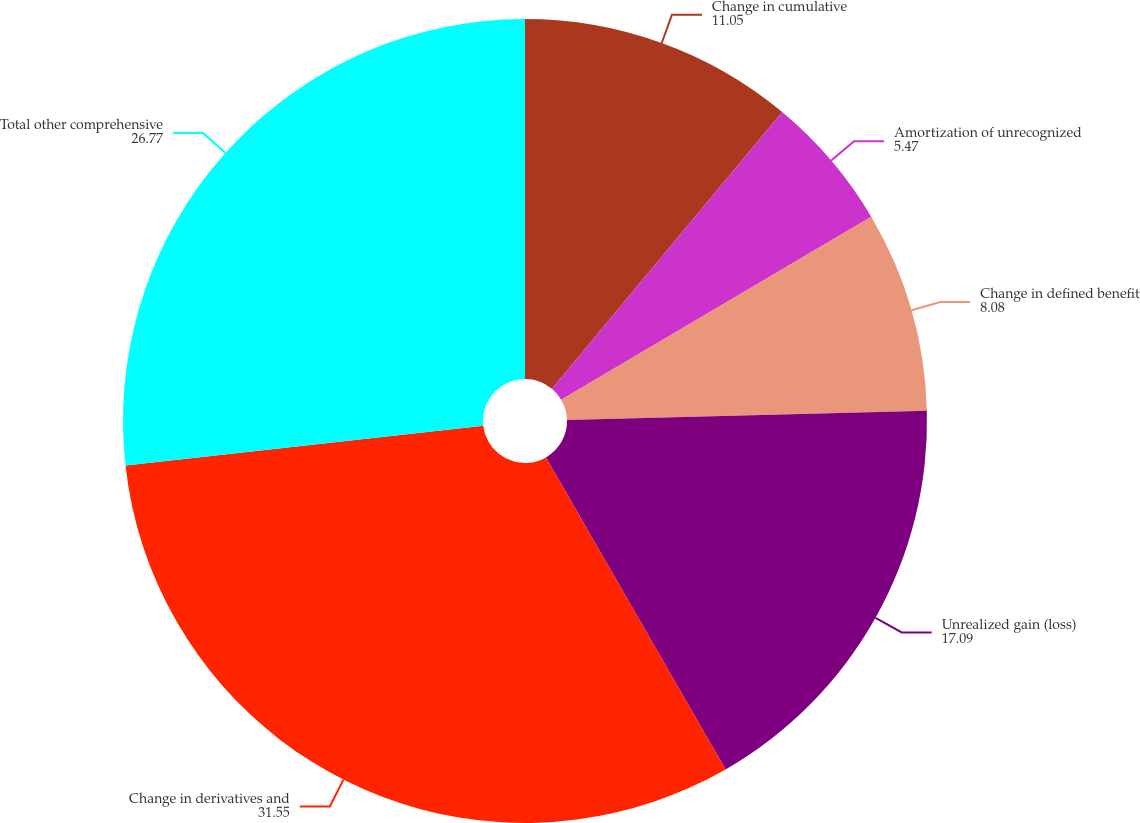Convert chart to OTSL. <chart><loc_0><loc_0><loc_500><loc_500><pie_chart><fcel>Change in cumulative<fcel>Amortization of unrecognized<fcel>Change in defined benefit<fcel>Unrealized gain (loss)<fcel>Change in derivatives and<fcel>Total other comprehensive<nl><fcel>11.05%<fcel>5.47%<fcel>8.08%<fcel>17.09%<fcel>31.55%<fcel>26.77%<nl></chart> 